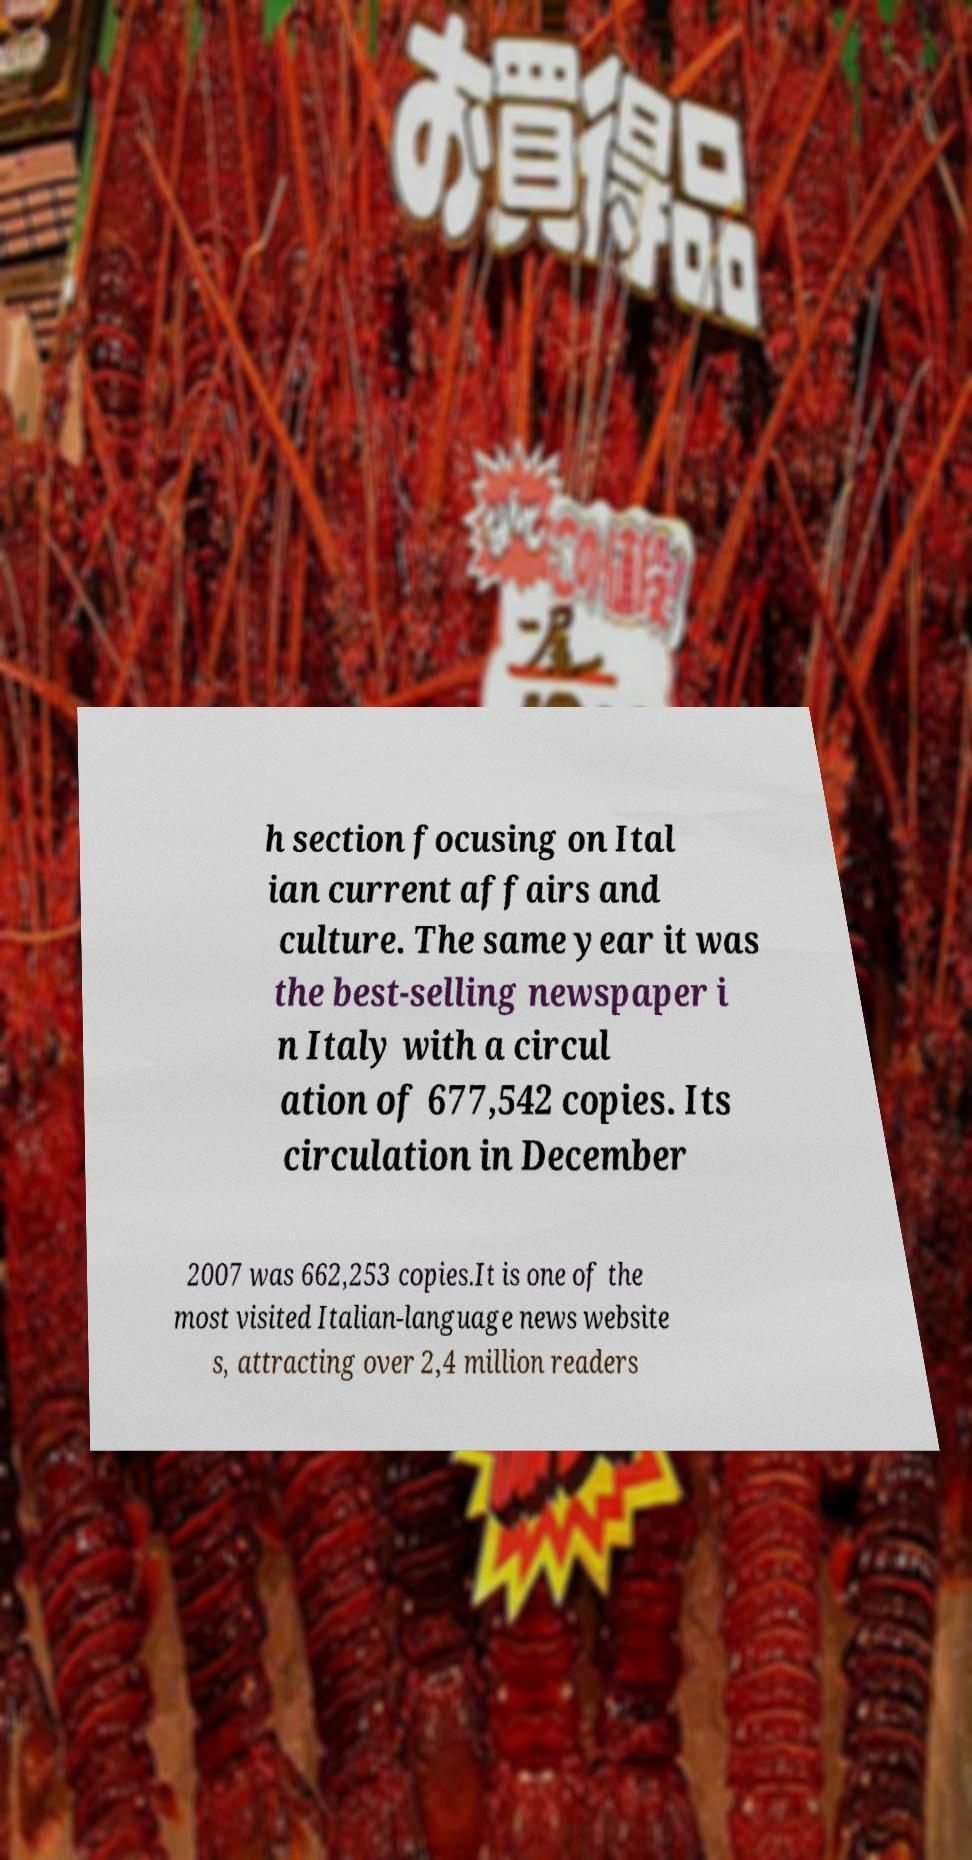Could you extract and type out the text from this image? h section focusing on Ital ian current affairs and culture. The same year it was the best-selling newspaper i n Italy with a circul ation of 677,542 copies. Its circulation in December 2007 was 662,253 copies.It is one of the most visited Italian-language news website s, attracting over 2,4 million readers 